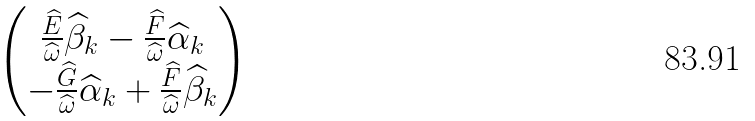Convert formula to latex. <formula><loc_0><loc_0><loc_500><loc_500>\begin{pmatrix} \frac { \widehat { E } } { \widehat { \omega } } { \widehat { \beta } } _ { k } - \frac { \widehat { F } } { \widehat { \omega } } { \widehat { \alpha } } _ { k } \\ - \frac { \widehat { G } } { \widehat { \omega } } { \widehat { \alpha } } _ { k } + \frac { \widehat { F } } { \widehat { \omega } } { \widehat { \beta } } _ { k } \end{pmatrix}</formula> 